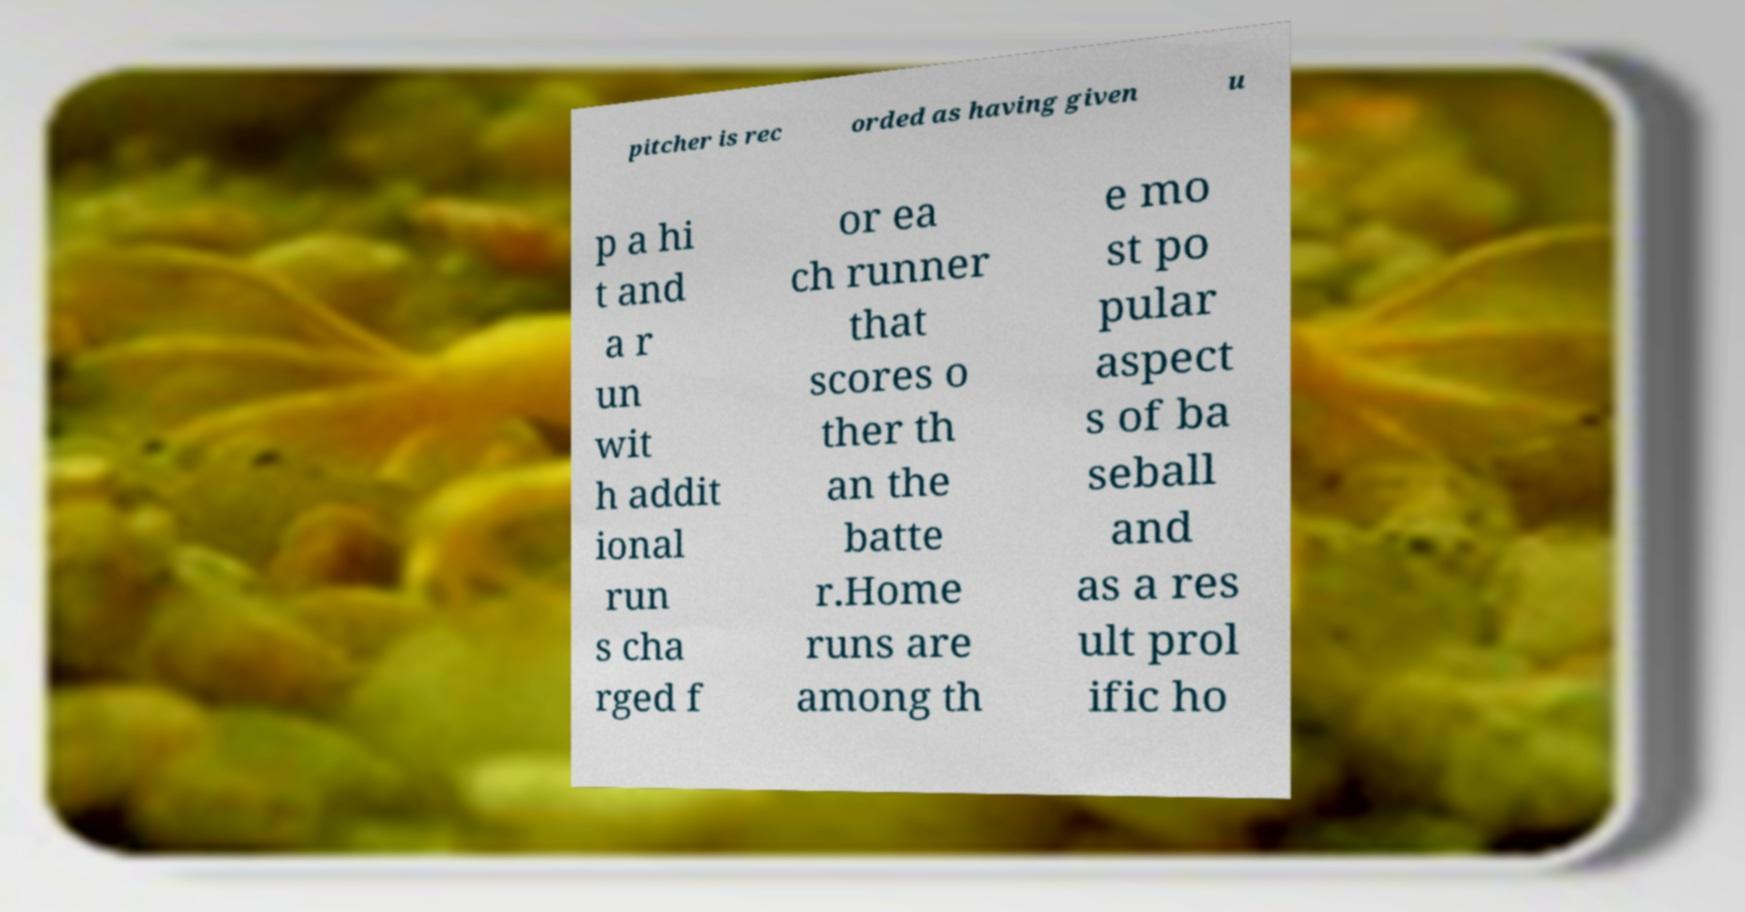For documentation purposes, I need the text within this image transcribed. Could you provide that? pitcher is rec orded as having given u p a hi t and a r un wit h addit ional run s cha rged f or ea ch runner that scores o ther th an the batte r.Home runs are among th e mo st po pular aspect s of ba seball and as a res ult prol ific ho 